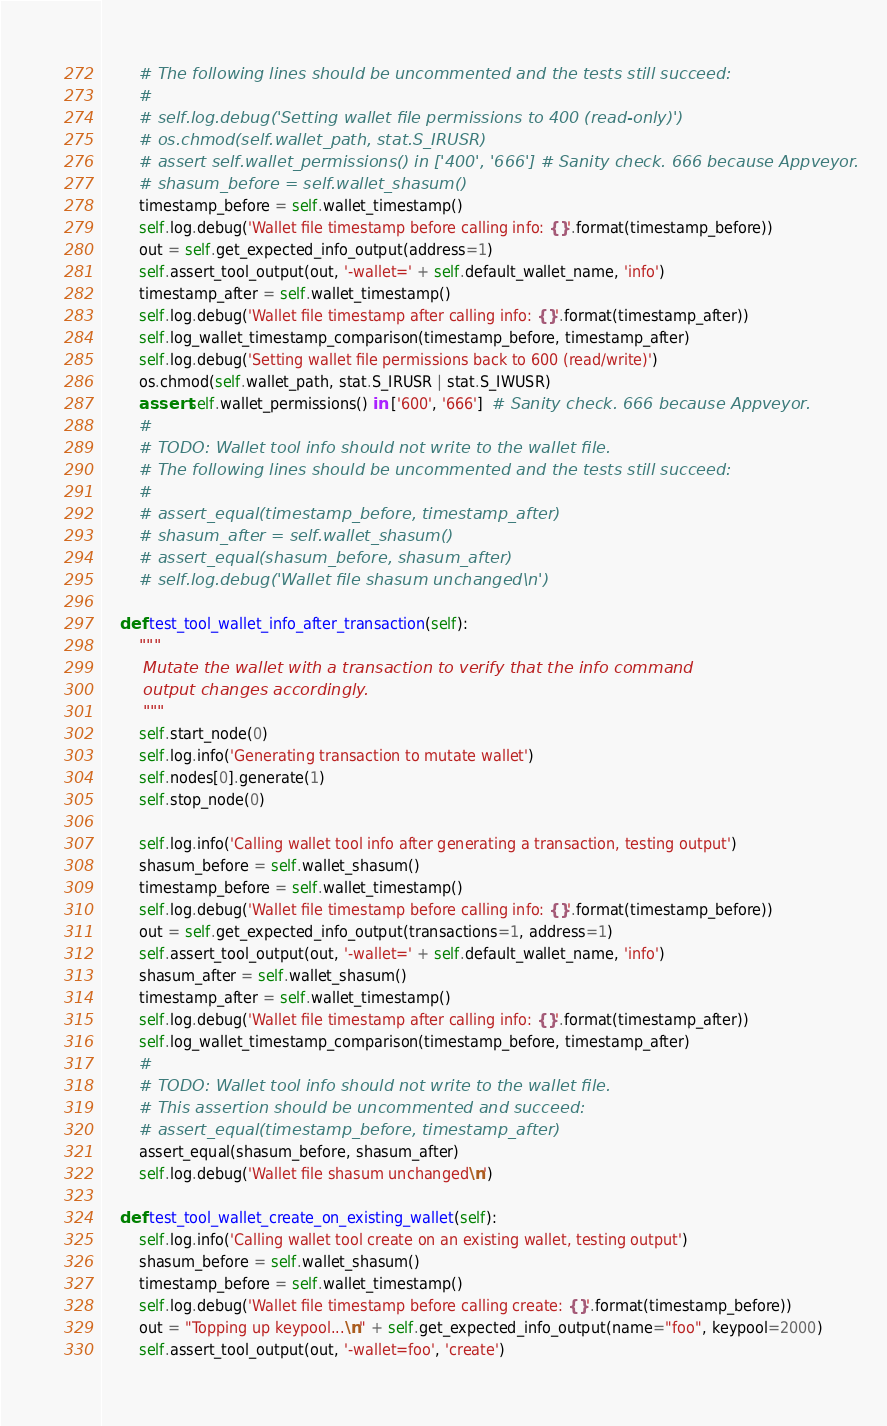Convert code to text. <code><loc_0><loc_0><loc_500><loc_500><_Python_>        # The following lines should be uncommented and the tests still succeed:
        #
        # self.log.debug('Setting wallet file permissions to 400 (read-only)')
        # os.chmod(self.wallet_path, stat.S_IRUSR)
        # assert self.wallet_permissions() in ['400', '666'] # Sanity check. 666 because Appveyor.
        # shasum_before = self.wallet_shasum()
        timestamp_before = self.wallet_timestamp()
        self.log.debug('Wallet file timestamp before calling info: {}'.format(timestamp_before))
        out = self.get_expected_info_output(address=1)
        self.assert_tool_output(out, '-wallet=' + self.default_wallet_name, 'info')
        timestamp_after = self.wallet_timestamp()
        self.log.debug('Wallet file timestamp after calling info: {}'.format(timestamp_after))
        self.log_wallet_timestamp_comparison(timestamp_before, timestamp_after)
        self.log.debug('Setting wallet file permissions back to 600 (read/write)')
        os.chmod(self.wallet_path, stat.S_IRUSR | stat.S_IWUSR)
        assert self.wallet_permissions() in ['600', '666']  # Sanity check. 666 because Appveyor.
        #
        # TODO: Wallet tool info should not write to the wallet file.
        # The following lines should be uncommented and the tests still succeed:
        #
        # assert_equal(timestamp_before, timestamp_after)
        # shasum_after = self.wallet_shasum()
        # assert_equal(shasum_before, shasum_after)
        # self.log.debug('Wallet file shasum unchanged\n')

    def test_tool_wallet_info_after_transaction(self):
        """
        Mutate the wallet with a transaction to verify that the info command
        output changes accordingly.
        """
        self.start_node(0)
        self.log.info('Generating transaction to mutate wallet')
        self.nodes[0].generate(1)
        self.stop_node(0)

        self.log.info('Calling wallet tool info after generating a transaction, testing output')
        shasum_before = self.wallet_shasum()
        timestamp_before = self.wallet_timestamp()
        self.log.debug('Wallet file timestamp before calling info: {}'.format(timestamp_before))
        out = self.get_expected_info_output(transactions=1, address=1)
        self.assert_tool_output(out, '-wallet=' + self.default_wallet_name, 'info')
        shasum_after = self.wallet_shasum()
        timestamp_after = self.wallet_timestamp()
        self.log.debug('Wallet file timestamp after calling info: {}'.format(timestamp_after))
        self.log_wallet_timestamp_comparison(timestamp_before, timestamp_after)
        #
        # TODO: Wallet tool info should not write to the wallet file.
        # This assertion should be uncommented and succeed:
        # assert_equal(timestamp_before, timestamp_after)
        assert_equal(shasum_before, shasum_after)
        self.log.debug('Wallet file shasum unchanged\n')

    def test_tool_wallet_create_on_existing_wallet(self):
        self.log.info('Calling wallet tool create on an existing wallet, testing output')
        shasum_before = self.wallet_shasum()
        timestamp_before = self.wallet_timestamp()
        self.log.debug('Wallet file timestamp before calling create: {}'.format(timestamp_before))
        out = "Topping up keypool...\n" + self.get_expected_info_output(name="foo", keypool=2000)
        self.assert_tool_output(out, '-wallet=foo', 'create')</code> 